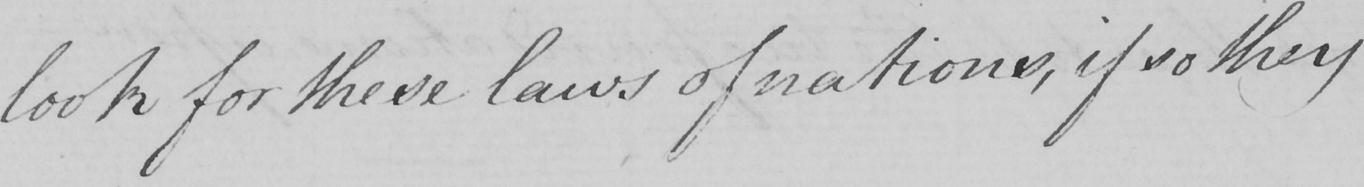Please provide the text content of this handwritten line. look for these laws of nations , if so they 